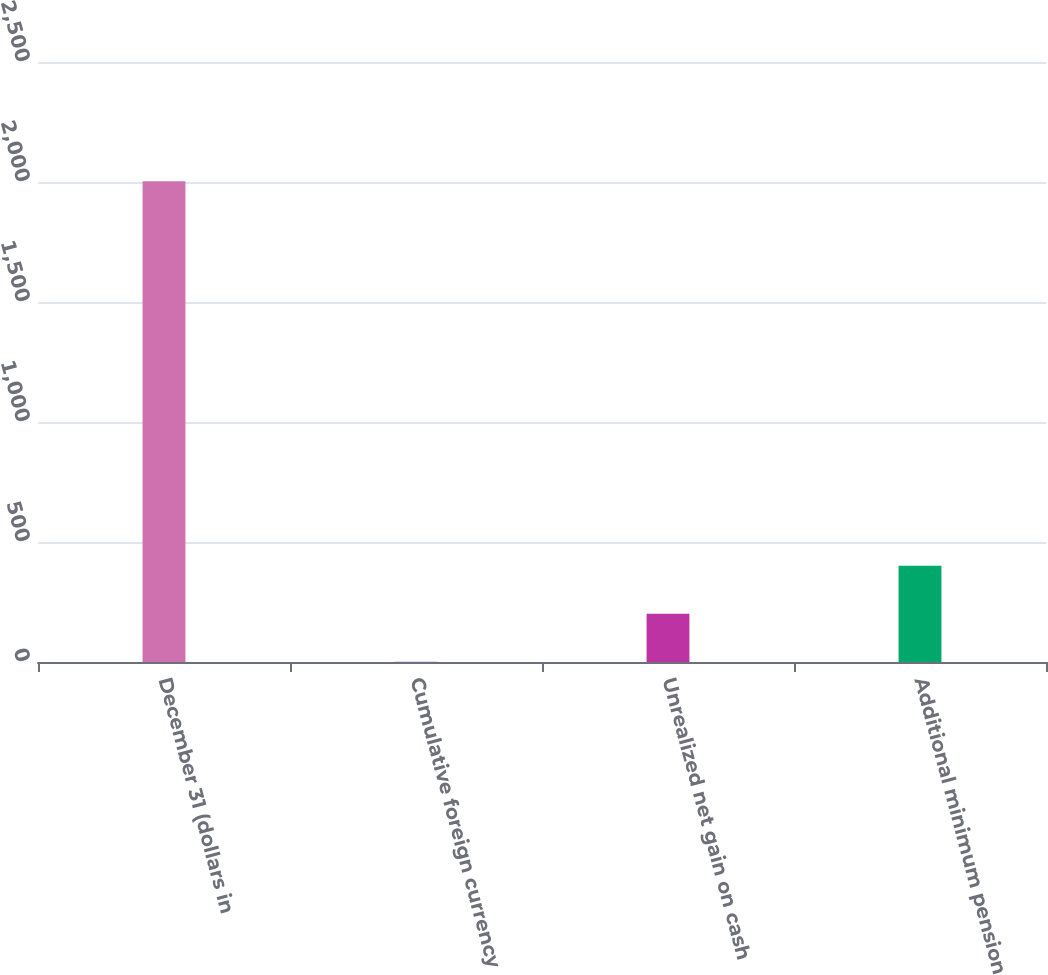<chart> <loc_0><loc_0><loc_500><loc_500><bar_chart><fcel>December 31 (dollars in<fcel>Cumulative foreign currency<fcel>Unrealized net gain on cash<fcel>Additional minimum pension<nl><fcel>2003<fcel>0.8<fcel>201.02<fcel>401.24<nl></chart> 